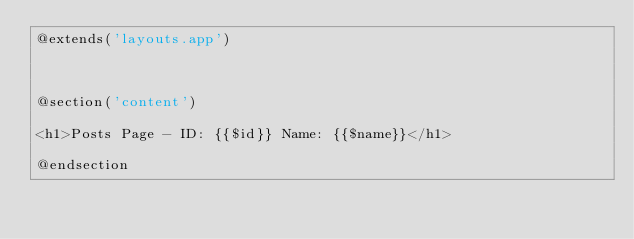<code> <loc_0><loc_0><loc_500><loc_500><_PHP_>@extends('layouts.app')



@section('content')

<h1>Posts Page - ID: {{$id}} Name: {{$name}}</h1>

@endsection</code> 